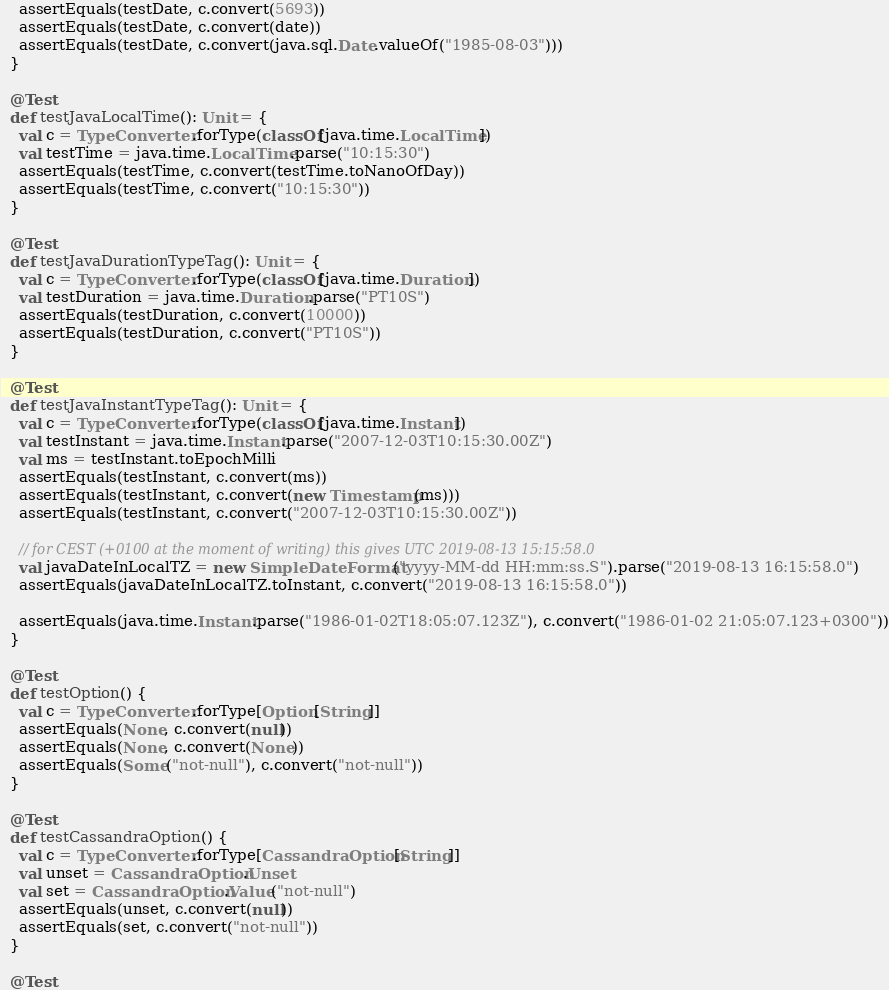Convert code to text. <code><loc_0><loc_0><loc_500><loc_500><_Scala_>    assertEquals(testDate, c.convert(5693))
    assertEquals(testDate, c.convert(date))
    assertEquals(testDate, c.convert(java.sql.Date.valueOf("1985-08-03")))
  }

  @Test
  def testJavaLocalTime(): Unit = {
    val c = TypeConverter.forType(classOf[java.time.LocalTime])
    val testTime = java.time.LocalTime.parse("10:15:30")
    assertEquals(testTime, c.convert(testTime.toNanoOfDay))
    assertEquals(testTime, c.convert("10:15:30"))
  }

  @Test
  def testJavaDurationTypeTag(): Unit = {
    val c = TypeConverter.forType(classOf[java.time.Duration])
    val testDuration = java.time.Duration.parse("PT10S")
    assertEquals(testDuration, c.convert(10000))
    assertEquals(testDuration, c.convert("PT10S"))
  }

  @Test
  def testJavaInstantTypeTag(): Unit = {
    val c = TypeConverter.forType(classOf[java.time.Instant])
    val testInstant = java.time.Instant.parse("2007-12-03T10:15:30.00Z")
    val ms = testInstant.toEpochMilli
    assertEquals(testInstant, c.convert(ms))
    assertEquals(testInstant, c.convert(new Timestamp(ms)))
    assertEquals(testInstant, c.convert("2007-12-03T10:15:30.00Z"))

    // for CEST (+0100 at the moment of writing) this gives UTC 2019-08-13 15:15:58.0
    val javaDateInLocalTZ = new SimpleDateFormat("yyyy-MM-dd HH:mm:ss.S").parse("2019-08-13 16:15:58.0")
    assertEquals(javaDateInLocalTZ.toInstant, c.convert("2019-08-13 16:15:58.0"))

    assertEquals(java.time.Instant.parse("1986-01-02T18:05:07.123Z"), c.convert("1986-01-02 21:05:07.123+0300"))
  }

  @Test
  def testOption() {
    val c = TypeConverter.forType[Option[String]]
    assertEquals(None, c.convert(null))
    assertEquals(None, c.convert(None))
    assertEquals(Some("not-null"), c.convert("not-null"))
  }

  @Test
  def testCassandraOption() {
    val c = TypeConverter.forType[CassandraOption[String]]
    val unset = CassandraOption.Unset
    val set = CassandraOption.Value("not-null")
    assertEquals(unset, c.convert(null))
    assertEquals(set, c.convert("not-null"))
  }

  @Test</code> 